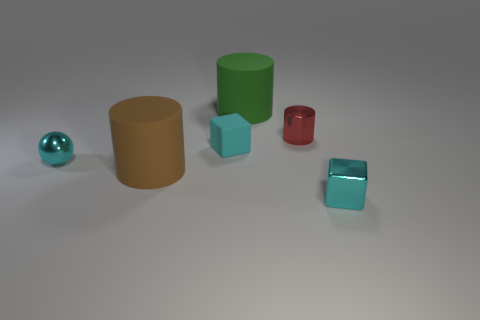Is there a cyan metallic block that is on the right side of the block to the right of the large green matte cylinder that is to the right of the cyan sphere? no 